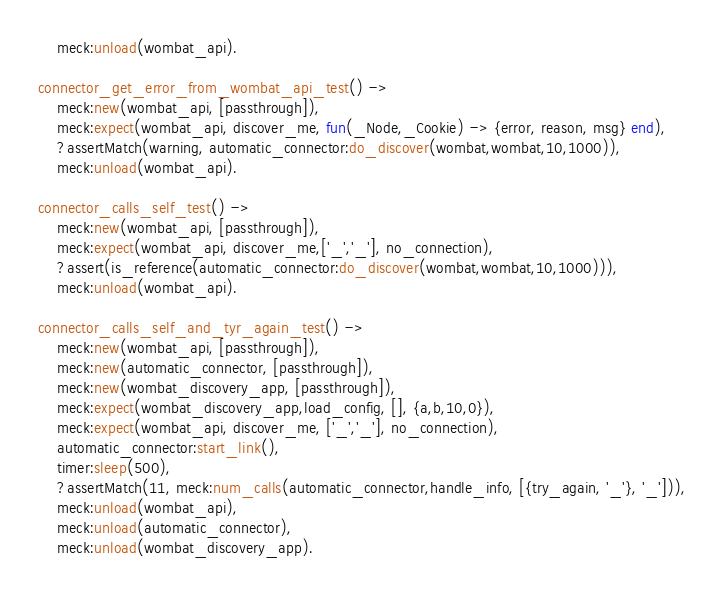<code> <loc_0><loc_0><loc_500><loc_500><_Erlang_>	meck:unload(wombat_api).

connector_get_error_from_wombat_api_test() ->
	meck:new(wombat_api, [passthrough]),
	meck:expect(wombat_api, discover_me, fun(_Node,_Cookie) -> {error, reason, msg} end),
	?assertMatch(warning, automatic_connector:do_discover(wombat,wombat,10,1000)),
	meck:unload(wombat_api).

connector_calls_self_test() ->
	meck:new(wombat_api, [passthrough]),
	meck:expect(wombat_api, discover_me,['_','_'], no_connection),
	?assert(is_reference(automatic_connector:do_discover(wombat,wombat,10,1000))),
	meck:unload(wombat_api).

connector_calls_self_and_tyr_again_test() ->
	meck:new(wombat_api, [passthrough]),
	meck:new(automatic_connector, [passthrough]),
	meck:new(wombat_discovery_app, [passthrough]),
	meck:expect(wombat_discovery_app,load_config, [], {a,b,10,0}),
	meck:expect(wombat_api, discover_me, ['_','_'], no_connection),
	automatic_connector:start_link(),
	timer:sleep(500),
	?assertMatch(11, meck:num_calls(automatic_connector,handle_info, [{try_again, '_'}, '_'])),
	meck:unload(wombat_api),
	meck:unload(automatic_connector),
	meck:unload(wombat_discovery_app).
</code> 